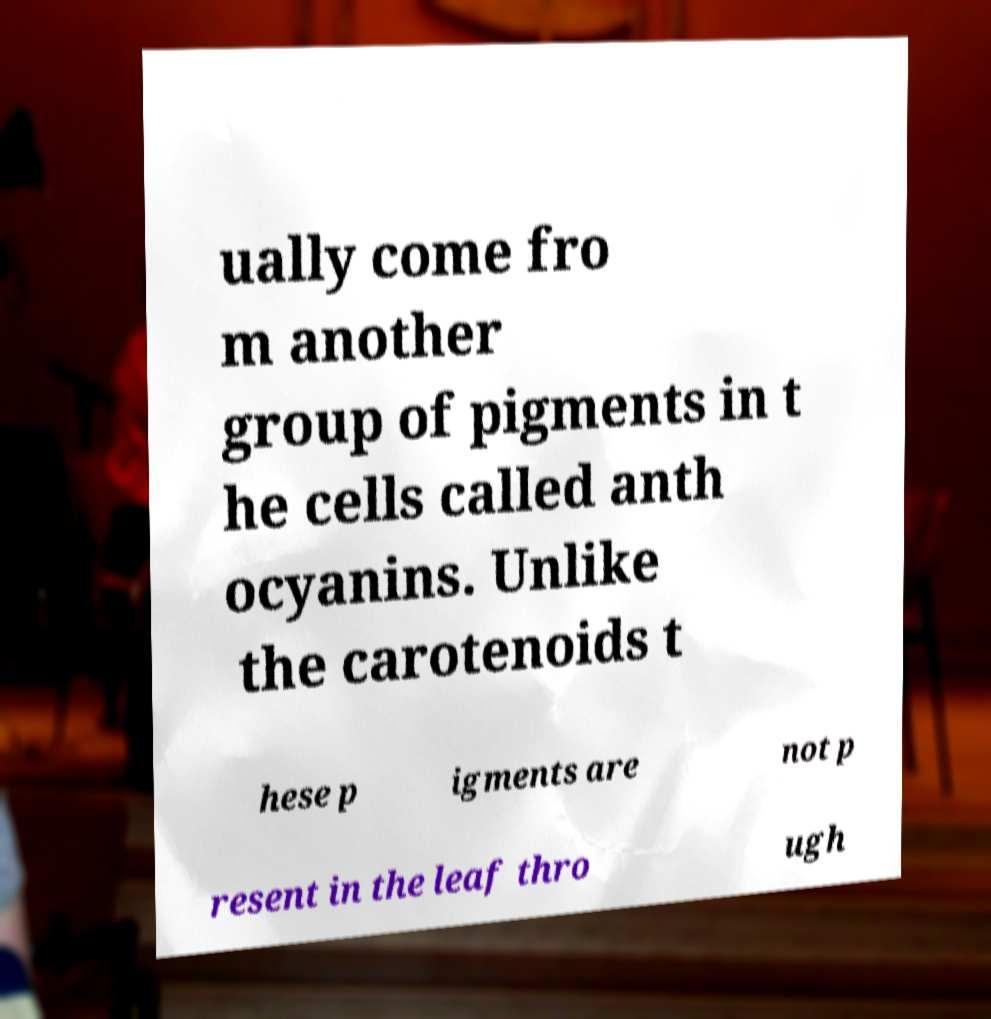I need the written content from this picture converted into text. Can you do that? ually come fro m another group of pigments in t he cells called anth ocyanins. Unlike the carotenoids t hese p igments are not p resent in the leaf thro ugh 